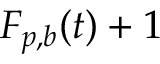<formula> <loc_0><loc_0><loc_500><loc_500>F _ { p , b } ( t ) + 1</formula> 